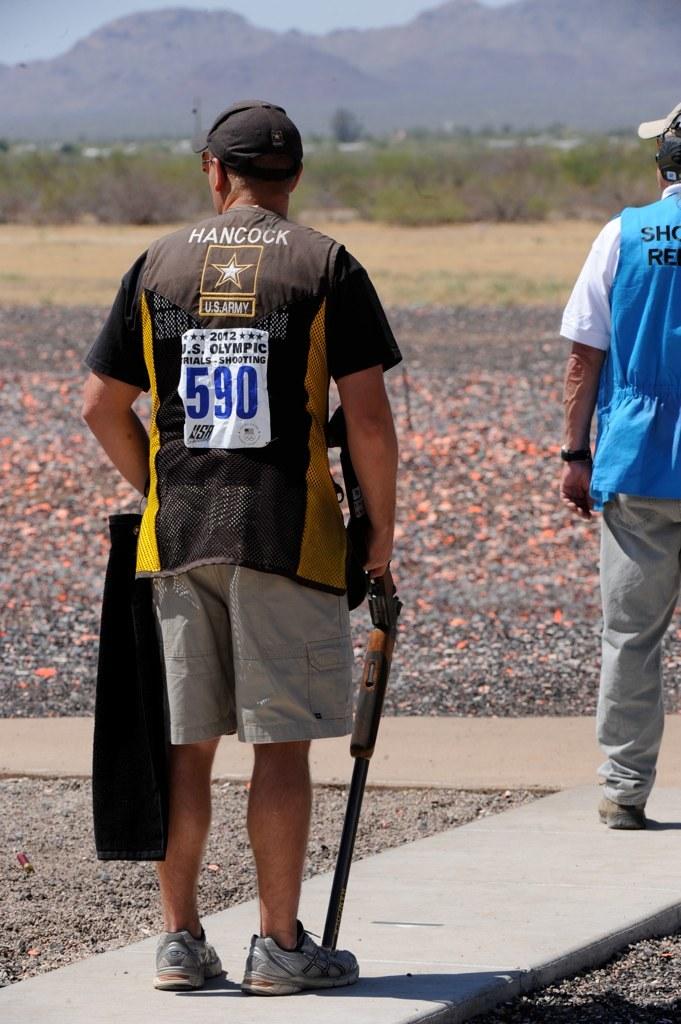What is the number?
Offer a terse response. 590. 